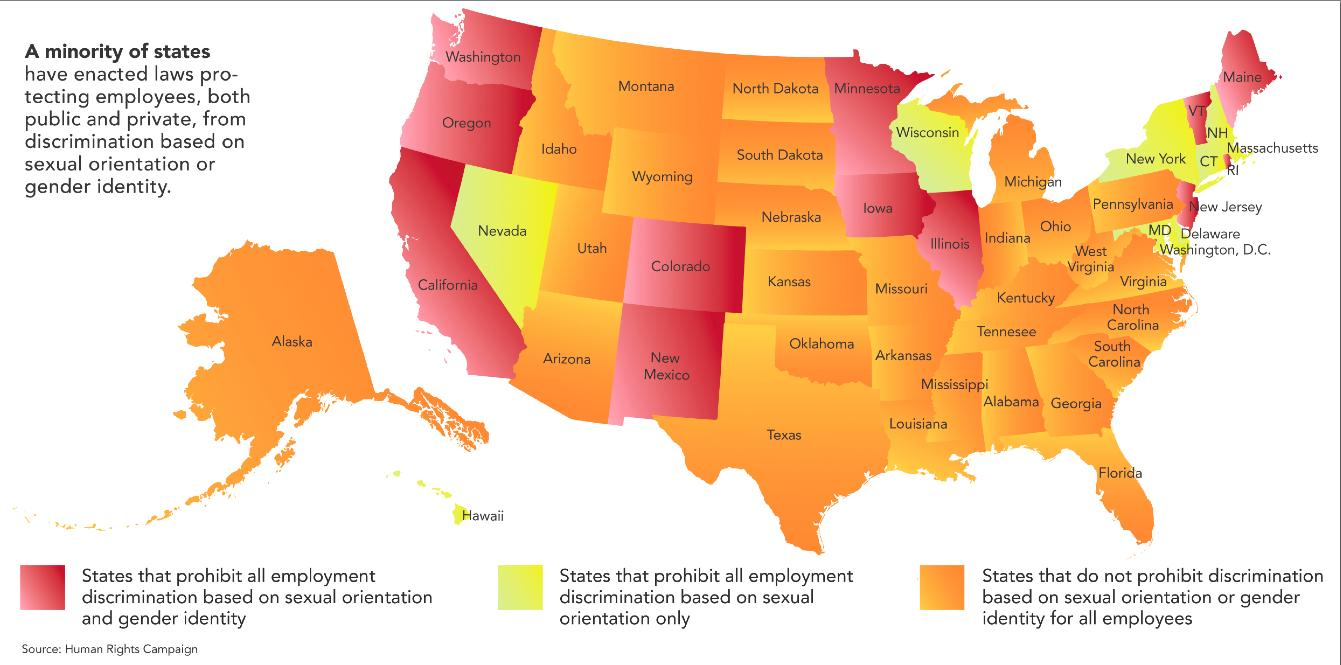Identify some key points in this picture. The color assigned to states that prohibit discrimination based only on sex orientation is yellow. Twelve states have prohibited all discrimination based on sex and gender. The states that have not prohibited discrimination based on sex or gender are given the color orange. The state that is an island and colored in orange in the information graphic is named Alaska. Hawaii is the state that is an island and colored in yellow in the infographic. 